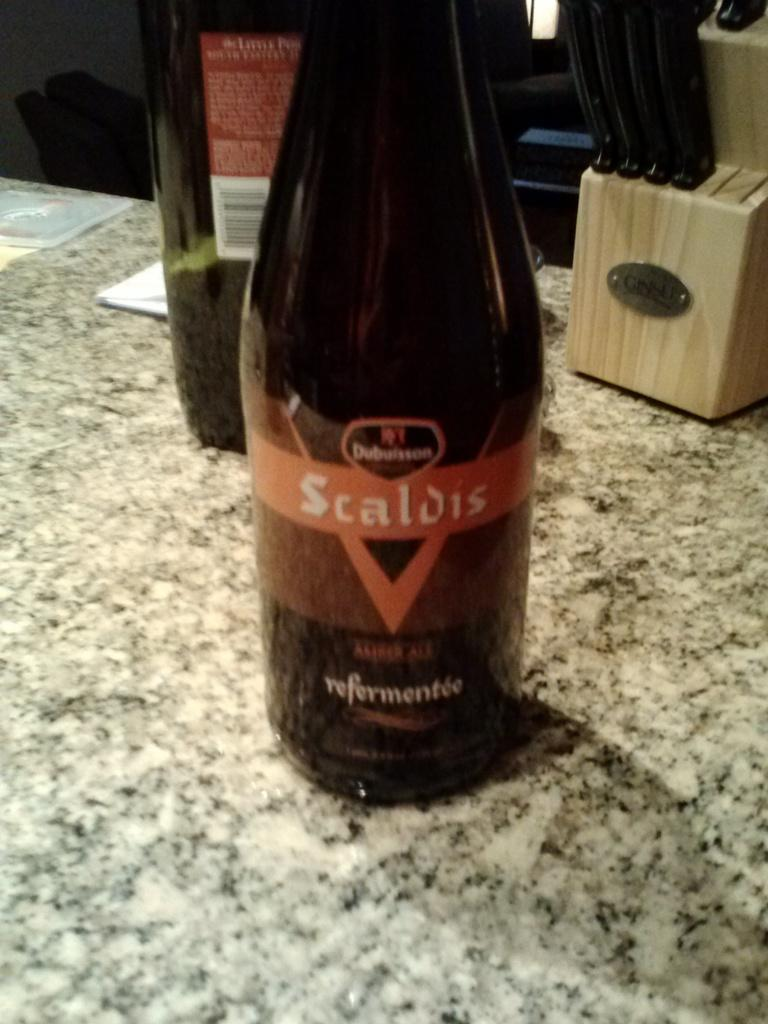<image>
Relay a brief, clear account of the picture shown. the name Scaldis that is on a wine bottle 